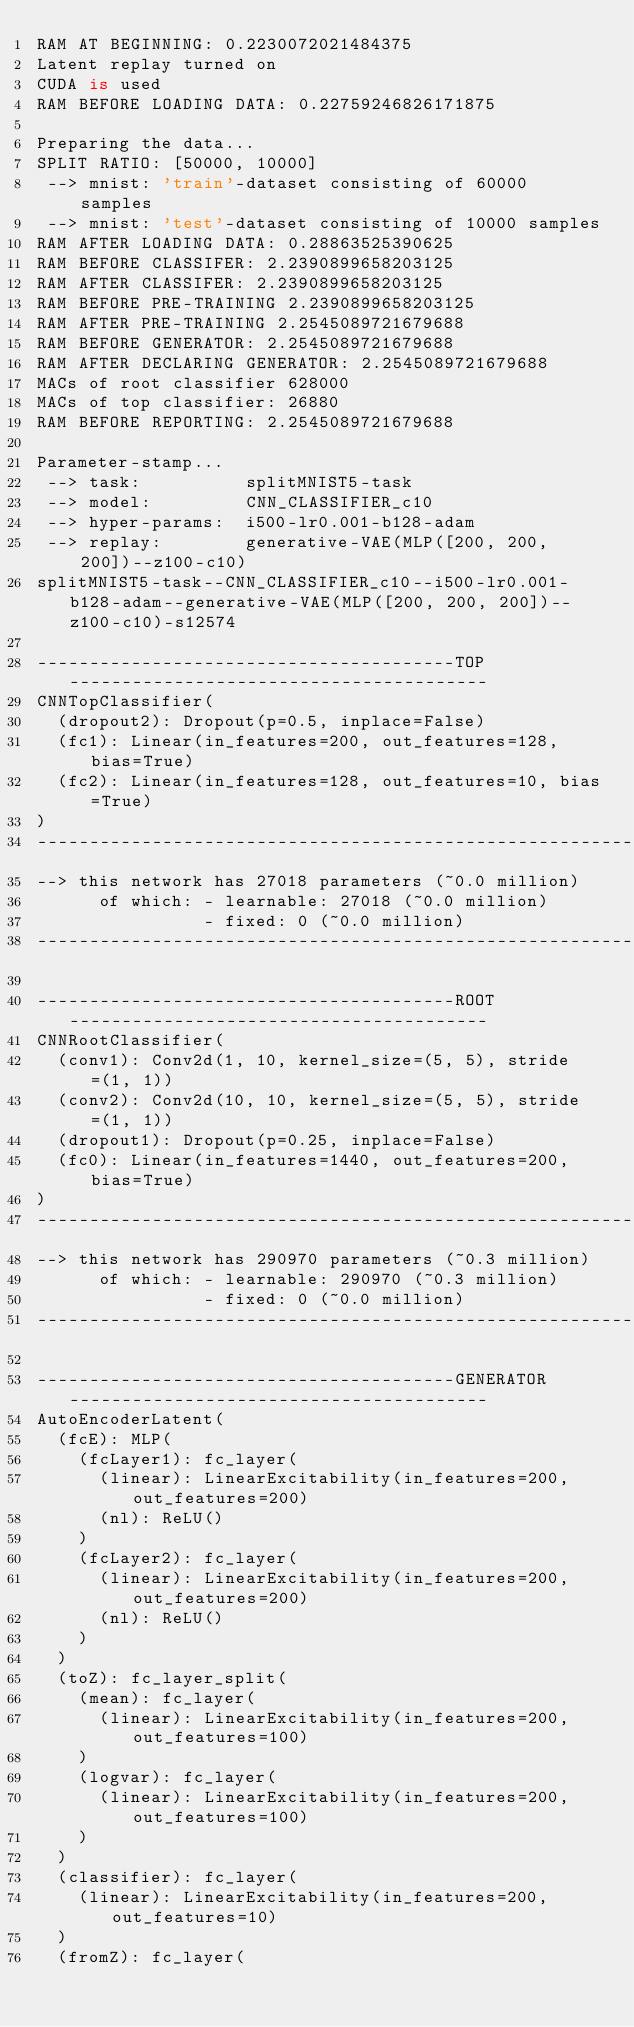Convert code to text. <code><loc_0><loc_0><loc_500><loc_500><_Python_>RAM AT BEGINNING: 0.2230072021484375
Latent replay turned on
CUDA is used
RAM BEFORE LOADING DATA: 0.22759246826171875

Preparing the data...
SPLIT RATIO: [50000, 10000]
 --> mnist: 'train'-dataset consisting of 60000 samples
 --> mnist: 'test'-dataset consisting of 10000 samples
RAM AFTER LOADING DATA: 0.28863525390625
RAM BEFORE CLASSIFER: 2.2390899658203125
RAM AFTER CLASSIFER: 2.2390899658203125
RAM BEFORE PRE-TRAINING 2.2390899658203125
RAM AFTER PRE-TRAINING 2.2545089721679688
RAM BEFORE GENERATOR: 2.2545089721679688
RAM AFTER DECLARING GENERATOR: 2.2545089721679688
MACs of root classifier 628000
MACs of top classifier: 26880
RAM BEFORE REPORTING: 2.2545089721679688

Parameter-stamp...
 --> task:          splitMNIST5-task
 --> model:         CNN_CLASSIFIER_c10
 --> hyper-params:  i500-lr0.001-b128-adam
 --> replay:        generative-VAE(MLP([200, 200, 200])--z100-c10)
splitMNIST5-task--CNN_CLASSIFIER_c10--i500-lr0.001-b128-adam--generative-VAE(MLP([200, 200, 200])--z100-c10)-s12574

----------------------------------------TOP----------------------------------------
CNNTopClassifier(
  (dropout2): Dropout(p=0.5, inplace=False)
  (fc1): Linear(in_features=200, out_features=128, bias=True)
  (fc2): Linear(in_features=128, out_features=10, bias=True)
)
------------------------------------------------------------------------------------------
--> this network has 27018 parameters (~0.0 million)
      of which: - learnable: 27018 (~0.0 million)
                - fixed: 0 (~0.0 million)
------------------------------------------------------------------------------------------

----------------------------------------ROOT----------------------------------------
CNNRootClassifier(
  (conv1): Conv2d(1, 10, kernel_size=(5, 5), stride=(1, 1))
  (conv2): Conv2d(10, 10, kernel_size=(5, 5), stride=(1, 1))
  (dropout1): Dropout(p=0.25, inplace=False)
  (fc0): Linear(in_features=1440, out_features=200, bias=True)
)
------------------------------------------------------------------------------------------
--> this network has 290970 parameters (~0.3 million)
      of which: - learnable: 290970 (~0.3 million)
                - fixed: 0 (~0.0 million)
------------------------------------------------------------------------------------------

----------------------------------------GENERATOR----------------------------------------
AutoEncoderLatent(
  (fcE): MLP(
    (fcLayer1): fc_layer(
      (linear): LinearExcitability(in_features=200, out_features=200)
      (nl): ReLU()
    )
    (fcLayer2): fc_layer(
      (linear): LinearExcitability(in_features=200, out_features=200)
      (nl): ReLU()
    )
  )
  (toZ): fc_layer_split(
    (mean): fc_layer(
      (linear): LinearExcitability(in_features=200, out_features=100)
    )
    (logvar): fc_layer(
      (linear): LinearExcitability(in_features=200, out_features=100)
    )
  )
  (classifier): fc_layer(
    (linear): LinearExcitability(in_features=200, out_features=10)
  )
  (fromZ): fc_layer(</code> 